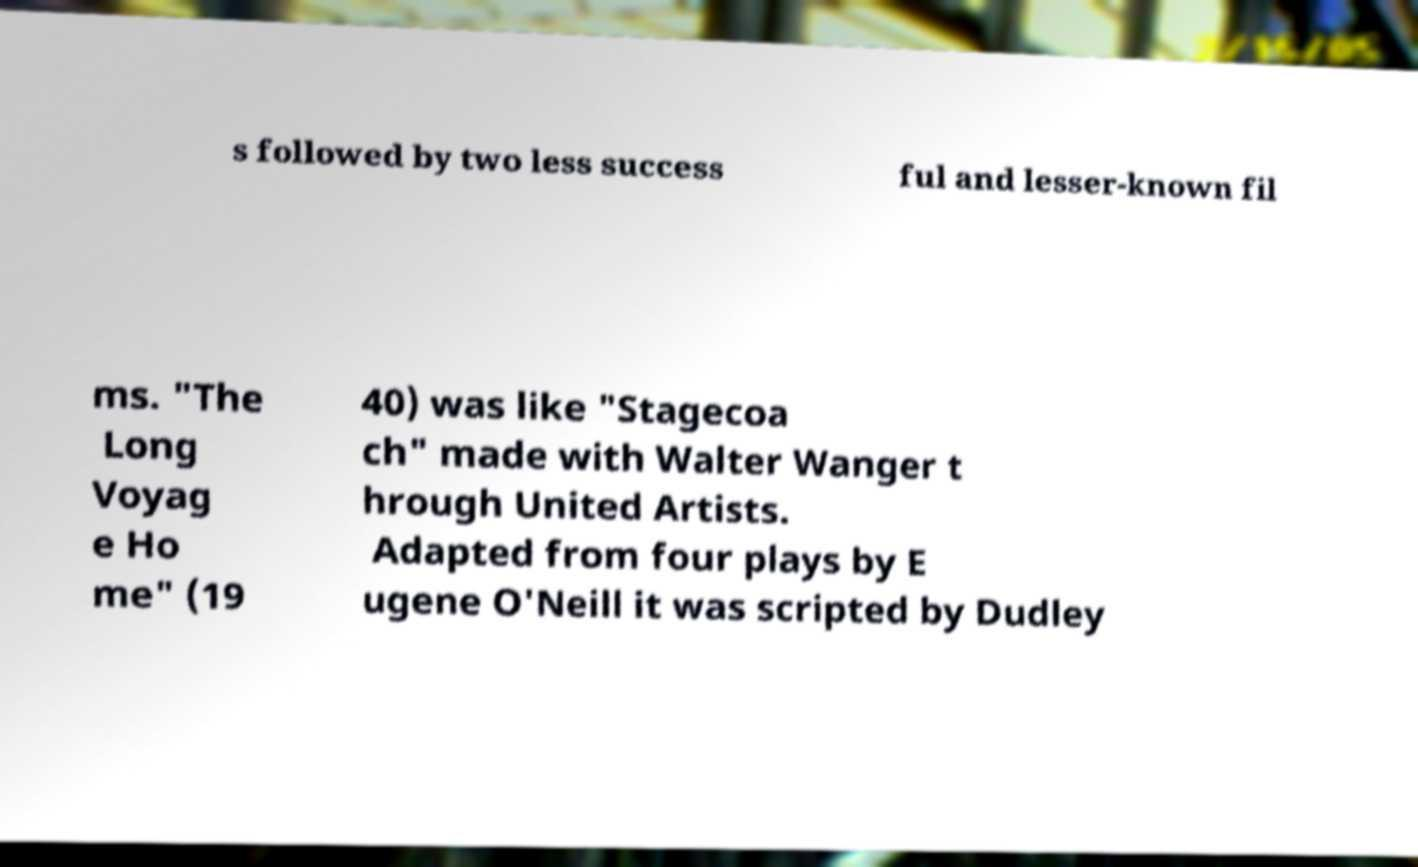There's text embedded in this image that I need extracted. Can you transcribe it verbatim? s followed by two less success ful and lesser-known fil ms. "The Long Voyag e Ho me" (19 40) was like "Stagecoa ch" made with Walter Wanger t hrough United Artists. Adapted from four plays by E ugene O'Neill it was scripted by Dudley 